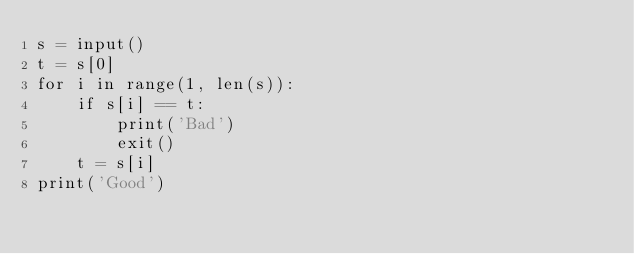<code> <loc_0><loc_0><loc_500><loc_500><_Python_>s = input()
t = s[0]
for i in range(1, len(s)):
    if s[i] == t:
        print('Bad')
        exit()
    t = s[i]
print('Good')
</code> 